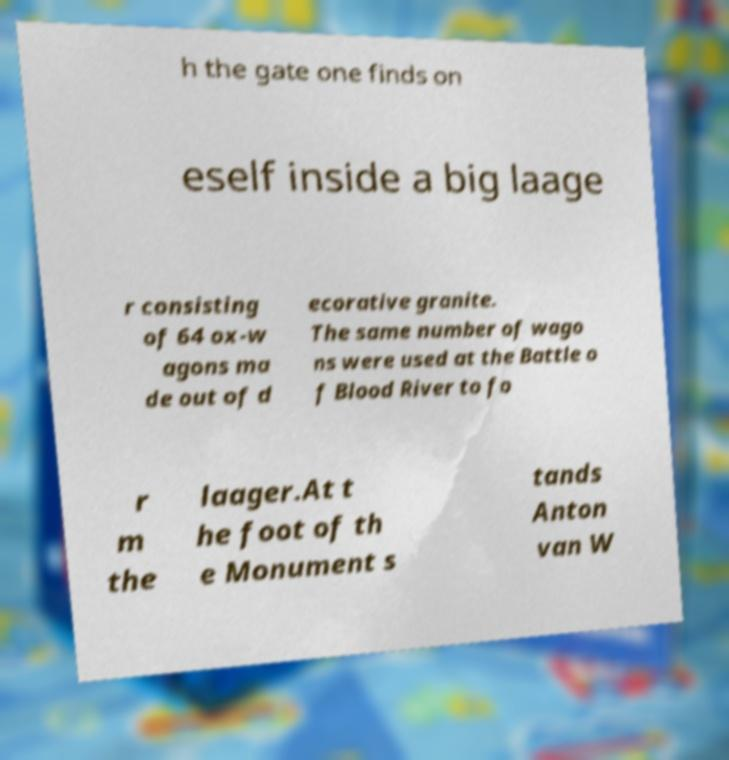What messages or text are displayed in this image? I need them in a readable, typed format. h the gate one finds on eself inside a big laage r consisting of 64 ox-w agons ma de out of d ecorative granite. The same number of wago ns were used at the Battle o f Blood River to fo r m the laager.At t he foot of th e Monument s tands Anton van W 